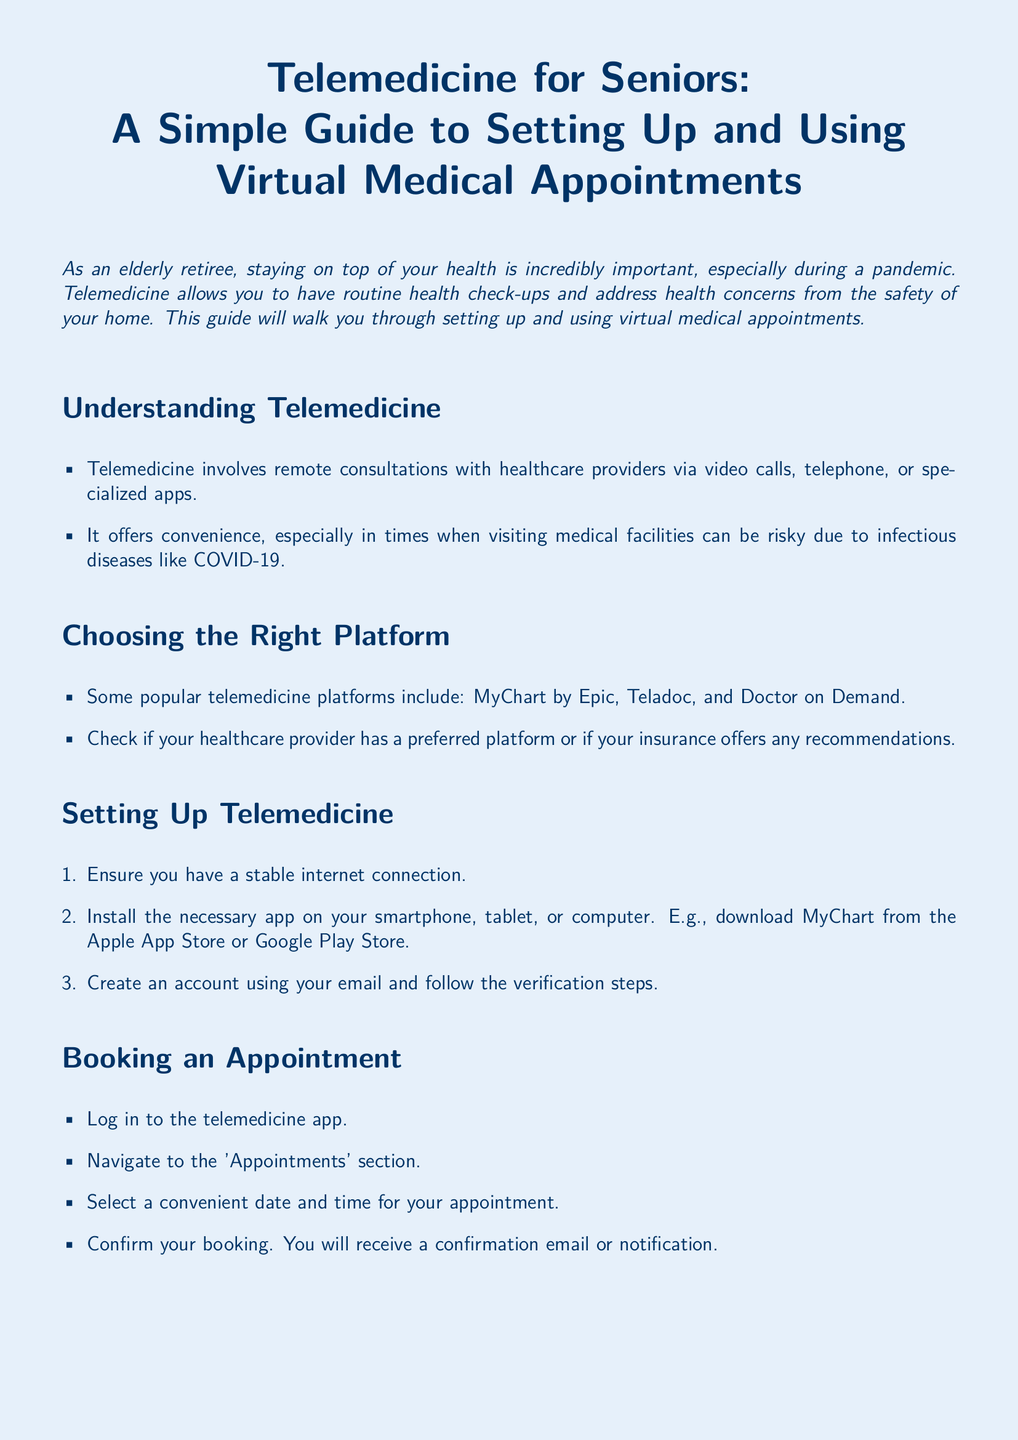What is the purpose of telemedicine? The purpose of telemedicine is to allow remote consultations with healthcare providers for routine health check-ups and health concerns from home.
Answer: To allow remote consultations What are two popular telemedicine platforms? The document lists several platforms; two examples provided are MyChart by Epic and Teladoc.
Answer: MyChart by Epic, Teladoc What should you ensure before setting up telemedicine? The initial setup for telemedicine requires ensuring a stable internet connection.
Answer: A stable internet connection What is the first step in booking an appointment? To book an appointment, you must log in to the telemedicine app as the first step.
Answer: Log in to the telemedicine app What should you do if you need clarification during your appointment? If clarification is needed during the appointment, you should not hesitate to ask your doctor to repeat or clarify information.
Answer: Ask your doctor to repeat What is a security tip mentioned in the document? One of the security tips includes using strong passwords for your telemedicine accounts.
Answer: Use strong passwords How can you prepare your device for the appointment? You should ensure your device is fully charged as part of your preparation for the appointment.
Answer: Device is fully charged What should you do after the appointment? After the appointment, it is important to follow any instructions given by your doctor and schedule follow-up appointments if necessary.
Answer: Follow any instructions What type of appointment is the guide focused on? The document specifically focuses on virtual medical appointments for routine health check-ups and pandemic-related issues.
Answer: Virtual medical appointments 